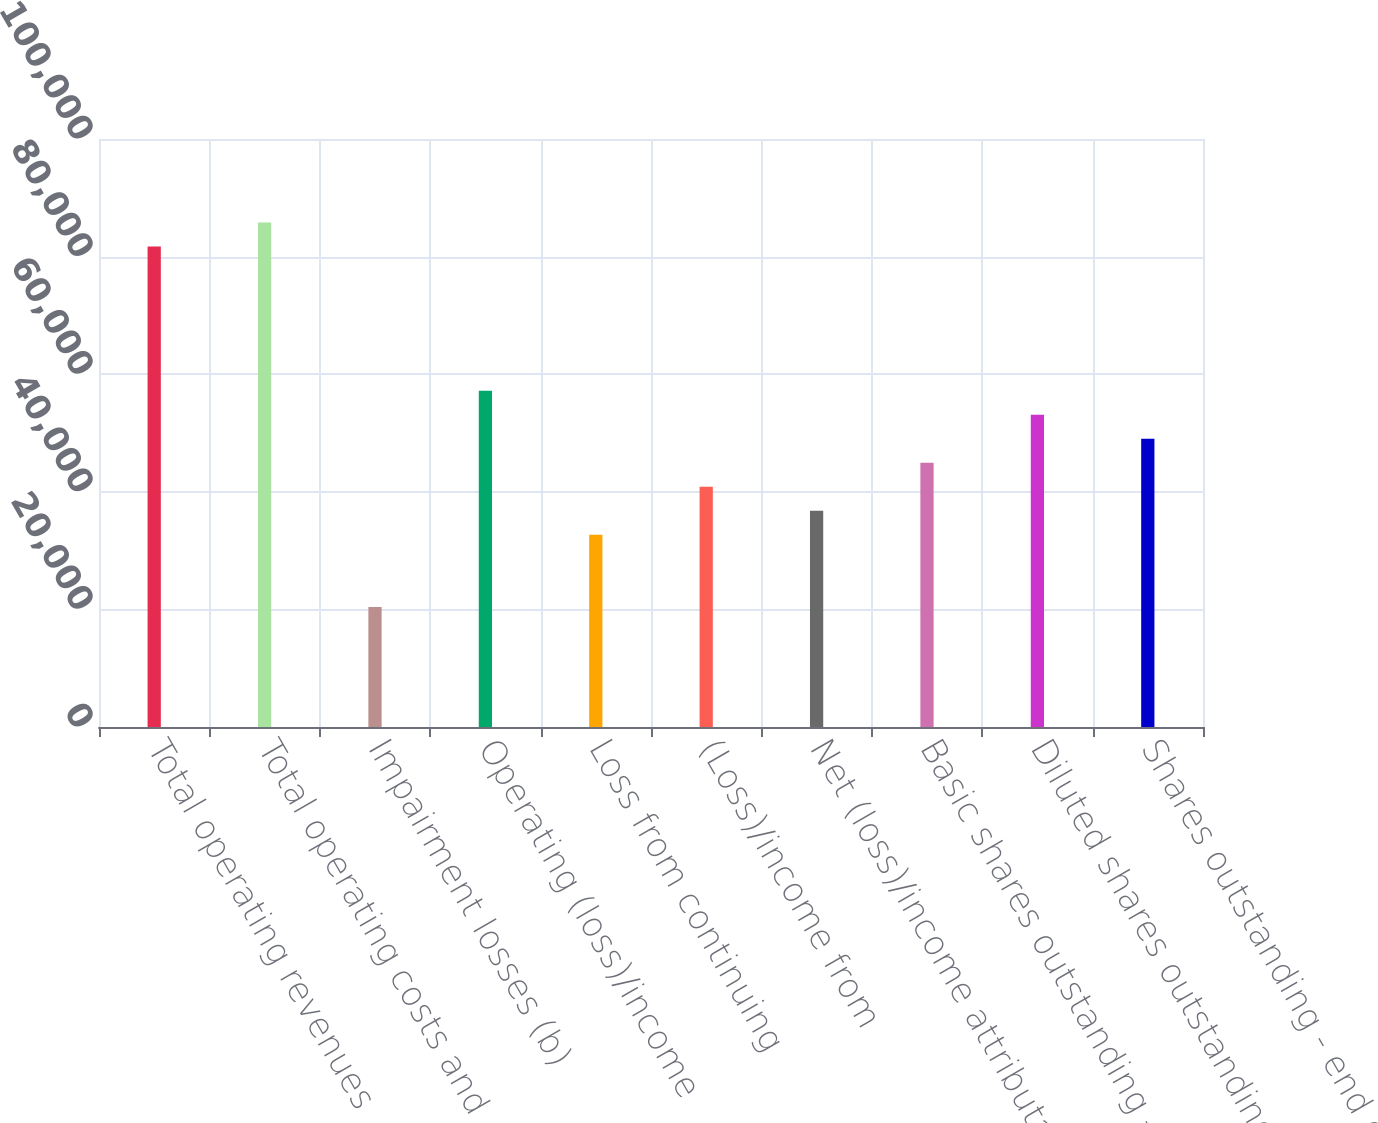Convert chart. <chart><loc_0><loc_0><loc_500><loc_500><bar_chart><fcel>Total operating revenues<fcel>Total operating costs and<fcel>Impairment losses (b)<fcel>Operating (loss)/income<fcel>Loss from continuing<fcel>(Loss)/income from<fcel>Net (loss)/income attributable<fcel>Basic shares outstanding -<fcel>Diluted shares outstanding -<fcel>Shares outstanding - end of<nl><fcel>81711.8<fcel>85797.4<fcel>20428.1<fcel>57198.3<fcel>32684.9<fcel>40856<fcel>36770.4<fcel>44941.6<fcel>53112.8<fcel>49027.2<nl></chart> 